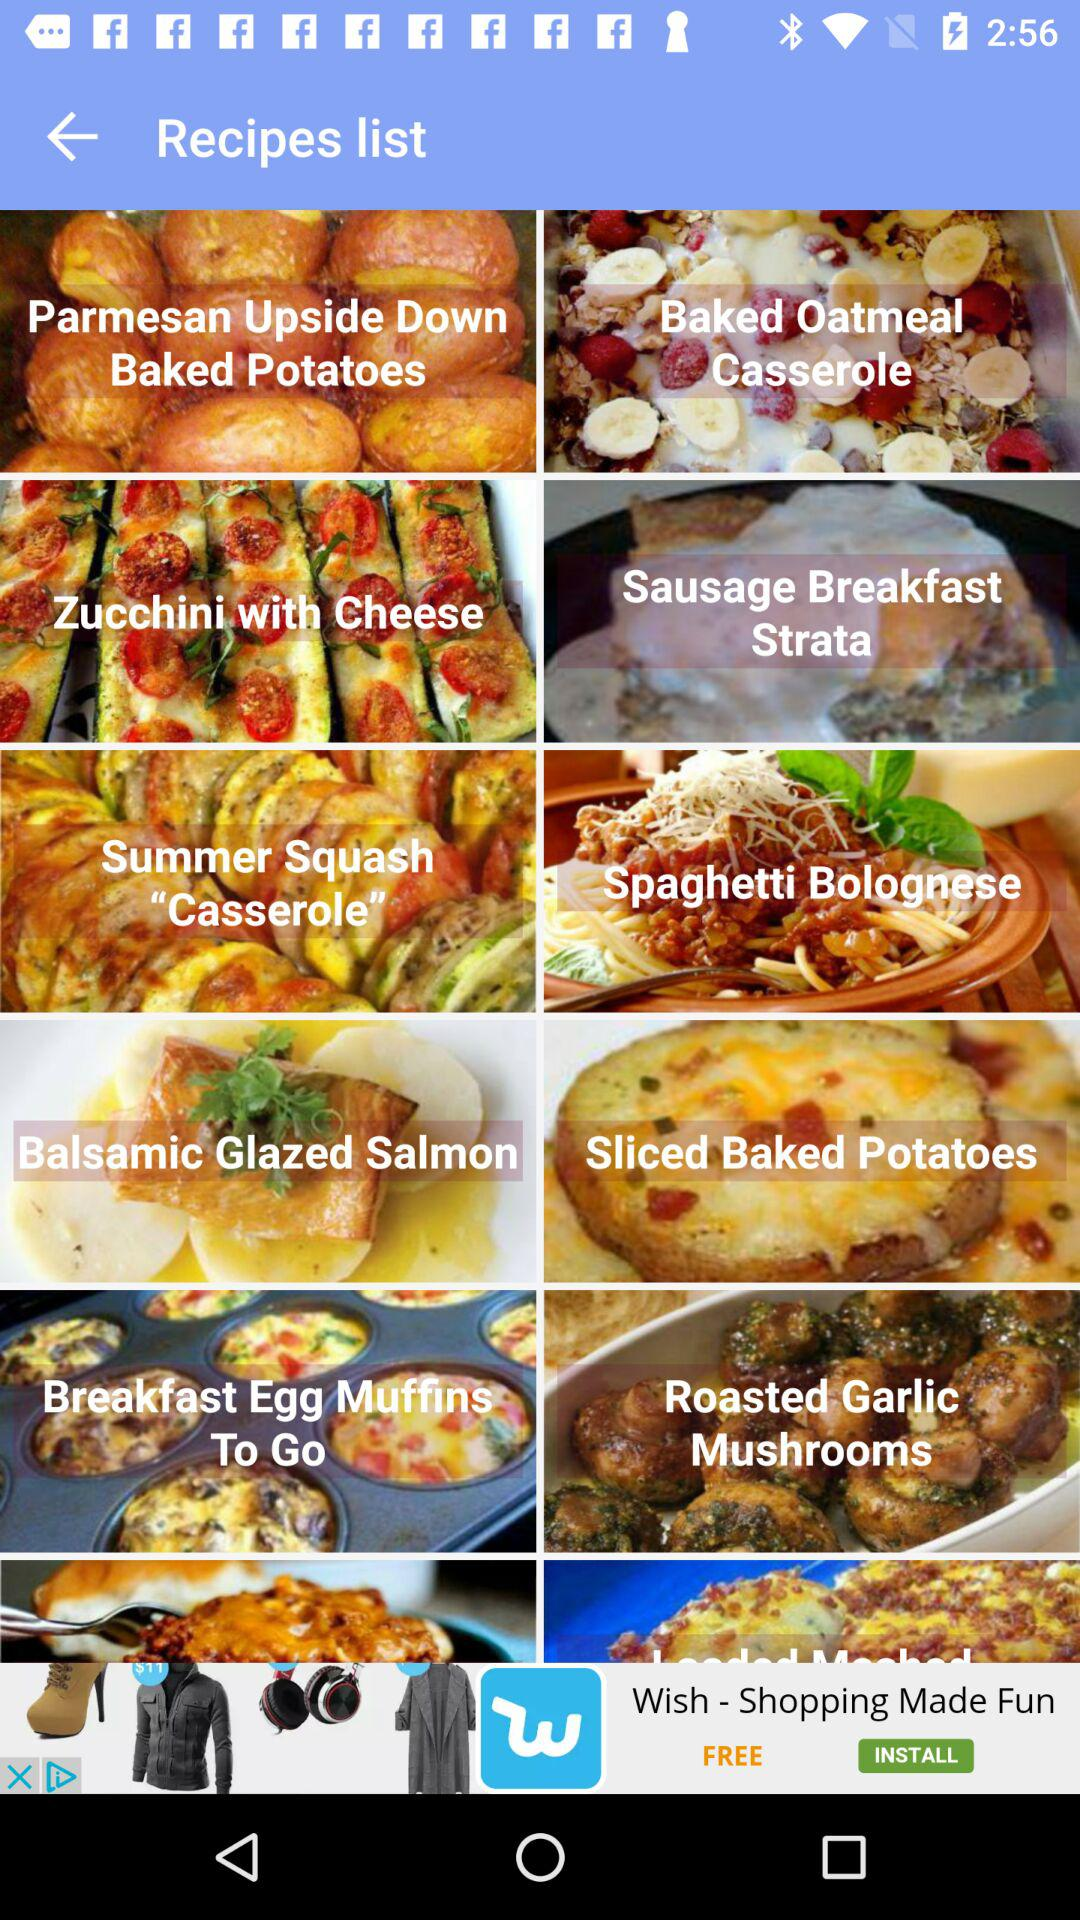Who is the user?
When the provided information is insufficient, respond with <no answer>. <no answer> 